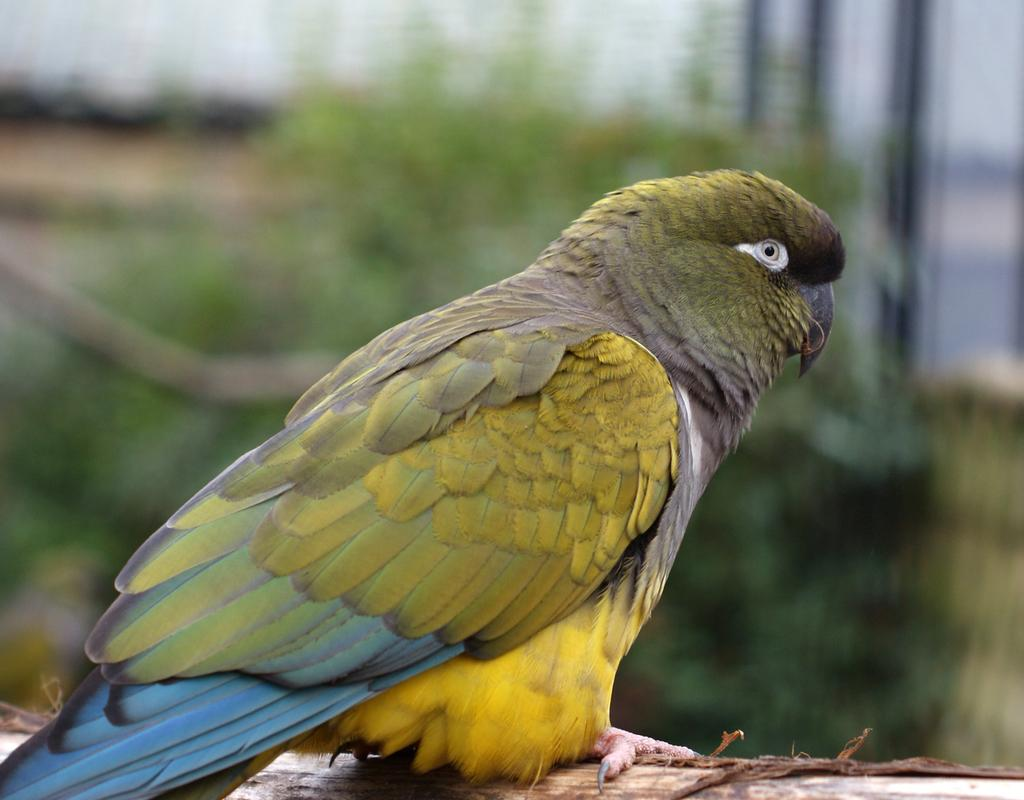What type of animal is in the image? There is a parrot in the image. Where is the parrot located? The parrot is sitting on a stem. What can be seen in the background of the image? There is a plant in the background of the image. How many girls are holding clams in the image? There are no girls or clams present in the image; it features a parrot sitting on a stem with a plant in the background. 